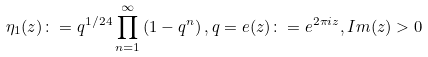Convert formula to latex. <formula><loc_0><loc_0><loc_500><loc_500>\eta _ { 1 } ( z ) \colon = q ^ { 1 / 2 4 } \prod ^ { \infty } _ { n = 1 } \left ( 1 - q ^ { n } \right ) , q = e ( z ) \colon = e ^ { 2 \pi i z } , I m ( z ) > 0</formula> 